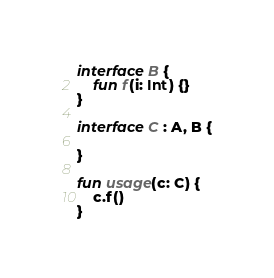<code> <loc_0><loc_0><loc_500><loc_500><_Kotlin_>interface B {
    fun f(i: Int) {}
}

interface C : A, B {

}

fun usage(c: C) {
    c.f()
}</code> 